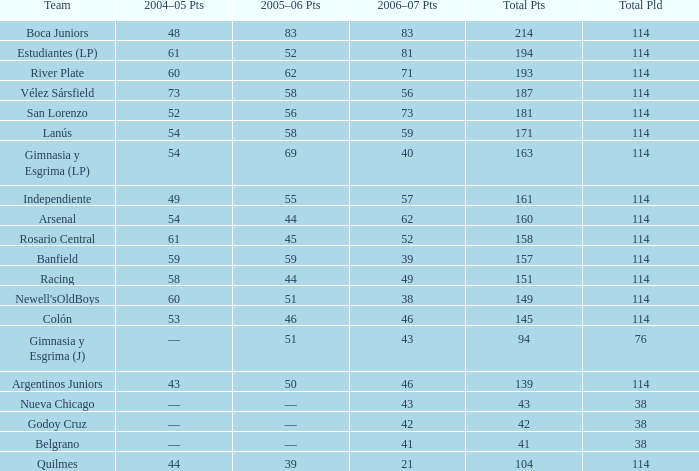What is the overall sum of points for a total pld below 38? 0.0. 